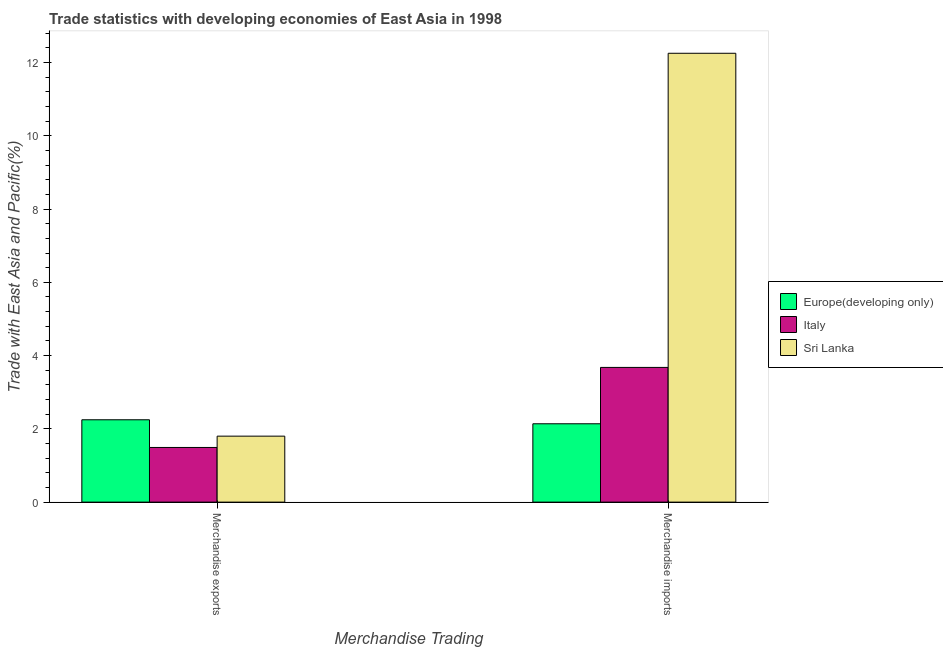How many groups of bars are there?
Your answer should be very brief. 2. Are the number of bars per tick equal to the number of legend labels?
Your response must be concise. Yes. Are the number of bars on each tick of the X-axis equal?
Offer a very short reply. Yes. How many bars are there on the 1st tick from the left?
Offer a terse response. 3. How many bars are there on the 1st tick from the right?
Offer a very short reply. 3. What is the merchandise exports in Europe(developing only)?
Your answer should be very brief. 2.25. Across all countries, what is the maximum merchandise imports?
Your answer should be compact. 12.25. Across all countries, what is the minimum merchandise imports?
Your answer should be compact. 2.14. In which country was the merchandise exports maximum?
Keep it short and to the point. Europe(developing only). In which country was the merchandise exports minimum?
Ensure brevity in your answer.  Italy. What is the total merchandise imports in the graph?
Offer a terse response. 18.07. What is the difference between the merchandise exports in Sri Lanka and that in Europe(developing only)?
Offer a terse response. -0.45. What is the difference between the merchandise exports in Sri Lanka and the merchandise imports in Italy?
Ensure brevity in your answer.  -1.88. What is the average merchandise exports per country?
Your answer should be compact. 1.85. What is the difference between the merchandise imports and merchandise exports in Italy?
Offer a terse response. 2.18. In how many countries, is the merchandise imports greater than 4 %?
Provide a succinct answer. 1. What is the ratio of the merchandise exports in Italy to that in Sri Lanka?
Your answer should be very brief. 0.83. What does the 1st bar from the left in Merchandise exports represents?
Offer a terse response. Europe(developing only). What does the 1st bar from the right in Merchandise imports represents?
Keep it short and to the point. Sri Lanka. How many bars are there?
Provide a short and direct response. 6. Are all the bars in the graph horizontal?
Provide a succinct answer. No. How many countries are there in the graph?
Ensure brevity in your answer.  3. Are the values on the major ticks of Y-axis written in scientific E-notation?
Provide a succinct answer. No. Does the graph contain any zero values?
Make the answer very short. No. How many legend labels are there?
Keep it short and to the point. 3. How are the legend labels stacked?
Your answer should be very brief. Vertical. What is the title of the graph?
Offer a terse response. Trade statistics with developing economies of East Asia in 1998. Does "Rwanda" appear as one of the legend labels in the graph?
Offer a terse response. No. What is the label or title of the X-axis?
Offer a terse response. Merchandise Trading. What is the label or title of the Y-axis?
Your response must be concise. Trade with East Asia and Pacific(%). What is the Trade with East Asia and Pacific(%) of Europe(developing only) in Merchandise exports?
Your answer should be very brief. 2.25. What is the Trade with East Asia and Pacific(%) of Italy in Merchandise exports?
Give a very brief answer. 1.49. What is the Trade with East Asia and Pacific(%) in Sri Lanka in Merchandise exports?
Your answer should be compact. 1.8. What is the Trade with East Asia and Pacific(%) of Europe(developing only) in Merchandise imports?
Offer a terse response. 2.14. What is the Trade with East Asia and Pacific(%) of Italy in Merchandise imports?
Offer a very short reply. 3.68. What is the Trade with East Asia and Pacific(%) of Sri Lanka in Merchandise imports?
Offer a terse response. 12.25. Across all Merchandise Trading, what is the maximum Trade with East Asia and Pacific(%) in Europe(developing only)?
Offer a very short reply. 2.25. Across all Merchandise Trading, what is the maximum Trade with East Asia and Pacific(%) of Italy?
Your response must be concise. 3.68. Across all Merchandise Trading, what is the maximum Trade with East Asia and Pacific(%) in Sri Lanka?
Ensure brevity in your answer.  12.25. Across all Merchandise Trading, what is the minimum Trade with East Asia and Pacific(%) of Europe(developing only)?
Make the answer very short. 2.14. Across all Merchandise Trading, what is the minimum Trade with East Asia and Pacific(%) of Italy?
Offer a terse response. 1.49. Across all Merchandise Trading, what is the minimum Trade with East Asia and Pacific(%) of Sri Lanka?
Provide a short and direct response. 1.8. What is the total Trade with East Asia and Pacific(%) of Europe(developing only) in the graph?
Your response must be concise. 4.39. What is the total Trade with East Asia and Pacific(%) in Italy in the graph?
Provide a succinct answer. 5.17. What is the total Trade with East Asia and Pacific(%) in Sri Lanka in the graph?
Your answer should be very brief. 14.05. What is the difference between the Trade with East Asia and Pacific(%) in Europe(developing only) in Merchandise exports and that in Merchandise imports?
Your answer should be very brief. 0.11. What is the difference between the Trade with East Asia and Pacific(%) of Italy in Merchandise exports and that in Merchandise imports?
Give a very brief answer. -2.18. What is the difference between the Trade with East Asia and Pacific(%) in Sri Lanka in Merchandise exports and that in Merchandise imports?
Provide a succinct answer. -10.45. What is the difference between the Trade with East Asia and Pacific(%) of Europe(developing only) in Merchandise exports and the Trade with East Asia and Pacific(%) of Italy in Merchandise imports?
Make the answer very short. -1.43. What is the difference between the Trade with East Asia and Pacific(%) of Europe(developing only) in Merchandise exports and the Trade with East Asia and Pacific(%) of Sri Lanka in Merchandise imports?
Offer a very short reply. -10.01. What is the difference between the Trade with East Asia and Pacific(%) of Italy in Merchandise exports and the Trade with East Asia and Pacific(%) of Sri Lanka in Merchandise imports?
Provide a short and direct response. -10.76. What is the average Trade with East Asia and Pacific(%) in Europe(developing only) per Merchandise Trading?
Make the answer very short. 2.19. What is the average Trade with East Asia and Pacific(%) of Italy per Merchandise Trading?
Your answer should be very brief. 2.58. What is the average Trade with East Asia and Pacific(%) of Sri Lanka per Merchandise Trading?
Your answer should be compact. 7.03. What is the difference between the Trade with East Asia and Pacific(%) in Europe(developing only) and Trade with East Asia and Pacific(%) in Italy in Merchandise exports?
Your answer should be compact. 0.76. What is the difference between the Trade with East Asia and Pacific(%) in Europe(developing only) and Trade with East Asia and Pacific(%) in Sri Lanka in Merchandise exports?
Your answer should be very brief. 0.45. What is the difference between the Trade with East Asia and Pacific(%) in Italy and Trade with East Asia and Pacific(%) in Sri Lanka in Merchandise exports?
Your answer should be very brief. -0.31. What is the difference between the Trade with East Asia and Pacific(%) in Europe(developing only) and Trade with East Asia and Pacific(%) in Italy in Merchandise imports?
Ensure brevity in your answer.  -1.54. What is the difference between the Trade with East Asia and Pacific(%) of Europe(developing only) and Trade with East Asia and Pacific(%) of Sri Lanka in Merchandise imports?
Make the answer very short. -10.11. What is the difference between the Trade with East Asia and Pacific(%) in Italy and Trade with East Asia and Pacific(%) in Sri Lanka in Merchandise imports?
Keep it short and to the point. -8.58. What is the ratio of the Trade with East Asia and Pacific(%) of Europe(developing only) in Merchandise exports to that in Merchandise imports?
Your answer should be compact. 1.05. What is the ratio of the Trade with East Asia and Pacific(%) in Italy in Merchandise exports to that in Merchandise imports?
Your response must be concise. 0.41. What is the ratio of the Trade with East Asia and Pacific(%) of Sri Lanka in Merchandise exports to that in Merchandise imports?
Provide a short and direct response. 0.15. What is the difference between the highest and the second highest Trade with East Asia and Pacific(%) in Europe(developing only)?
Offer a terse response. 0.11. What is the difference between the highest and the second highest Trade with East Asia and Pacific(%) of Italy?
Your response must be concise. 2.18. What is the difference between the highest and the second highest Trade with East Asia and Pacific(%) in Sri Lanka?
Give a very brief answer. 10.45. What is the difference between the highest and the lowest Trade with East Asia and Pacific(%) of Europe(developing only)?
Your answer should be very brief. 0.11. What is the difference between the highest and the lowest Trade with East Asia and Pacific(%) of Italy?
Your answer should be very brief. 2.18. What is the difference between the highest and the lowest Trade with East Asia and Pacific(%) of Sri Lanka?
Your response must be concise. 10.45. 